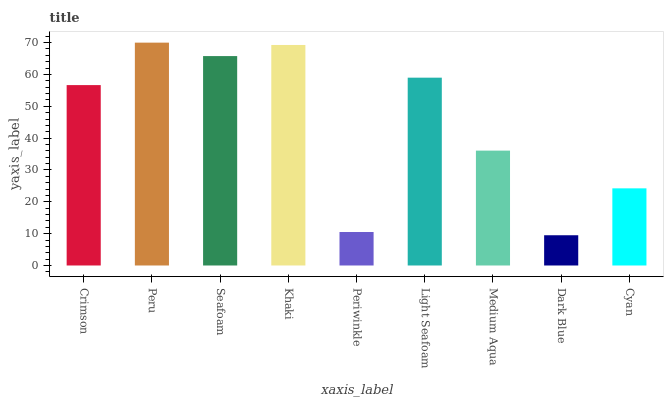Is Dark Blue the minimum?
Answer yes or no. Yes. Is Peru the maximum?
Answer yes or no. Yes. Is Seafoam the minimum?
Answer yes or no. No. Is Seafoam the maximum?
Answer yes or no. No. Is Peru greater than Seafoam?
Answer yes or no. Yes. Is Seafoam less than Peru?
Answer yes or no. Yes. Is Seafoam greater than Peru?
Answer yes or no. No. Is Peru less than Seafoam?
Answer yes or no. No. Is Crimson the high median?
Answer yes or no. Yes. Is Crimson the low median?
Answer yes or no. Yes. Is Khaki the high median?
Answer yes or no. No. Is Dark Blue the low median?
Answer yes or no. No. 